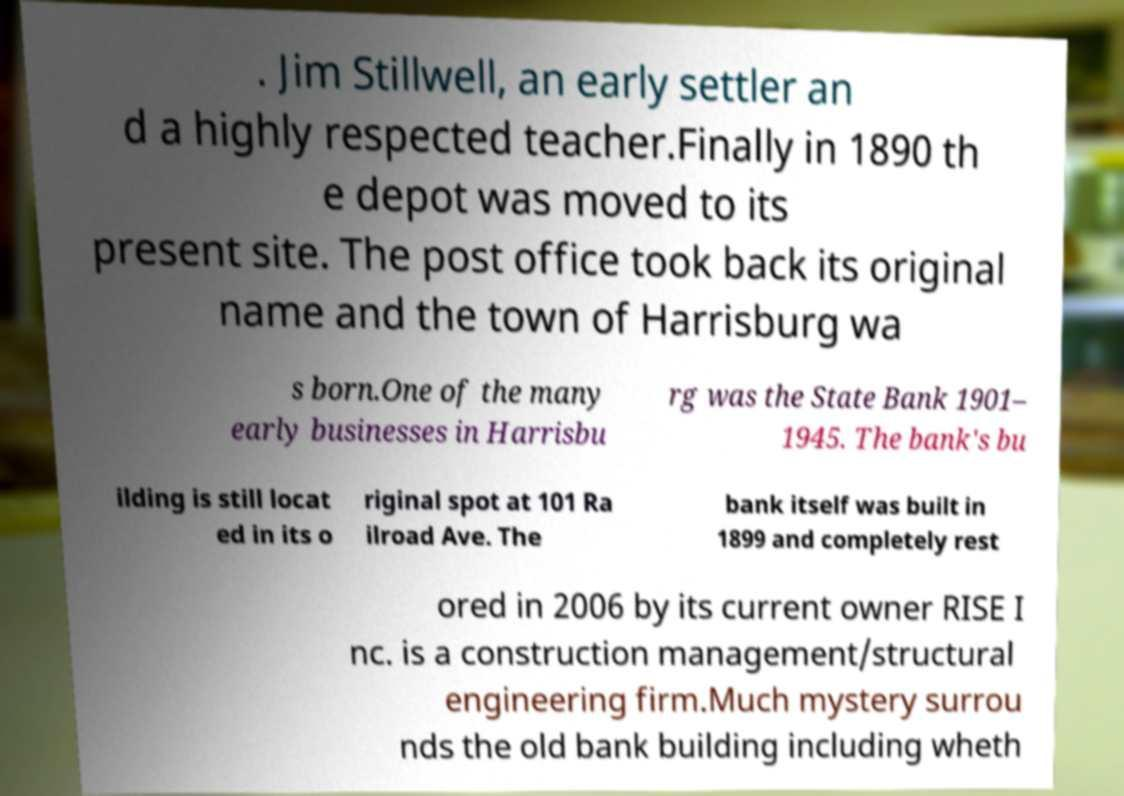Please identify and transcribe the text found in this image. . Jim Stillwell, an early settler an d a highly respected teacher.Finally in 1890 th e depot was moved to its present site. The post office took back its original name and the town of Harrisburg wa s born.One of the many early businesses in Harrisbu rg was the State Bank 1901– 1945. The bank's bu ilding is still locat ed in its o riginal spot at 101 Ra ilroad Ave. The bank itself was built in 1899 and completely rest ored in 2006 by its current owner RISE I nc. is a construction management/structural engineering firm.Much mystery surrou nds the old bank building including wheth 